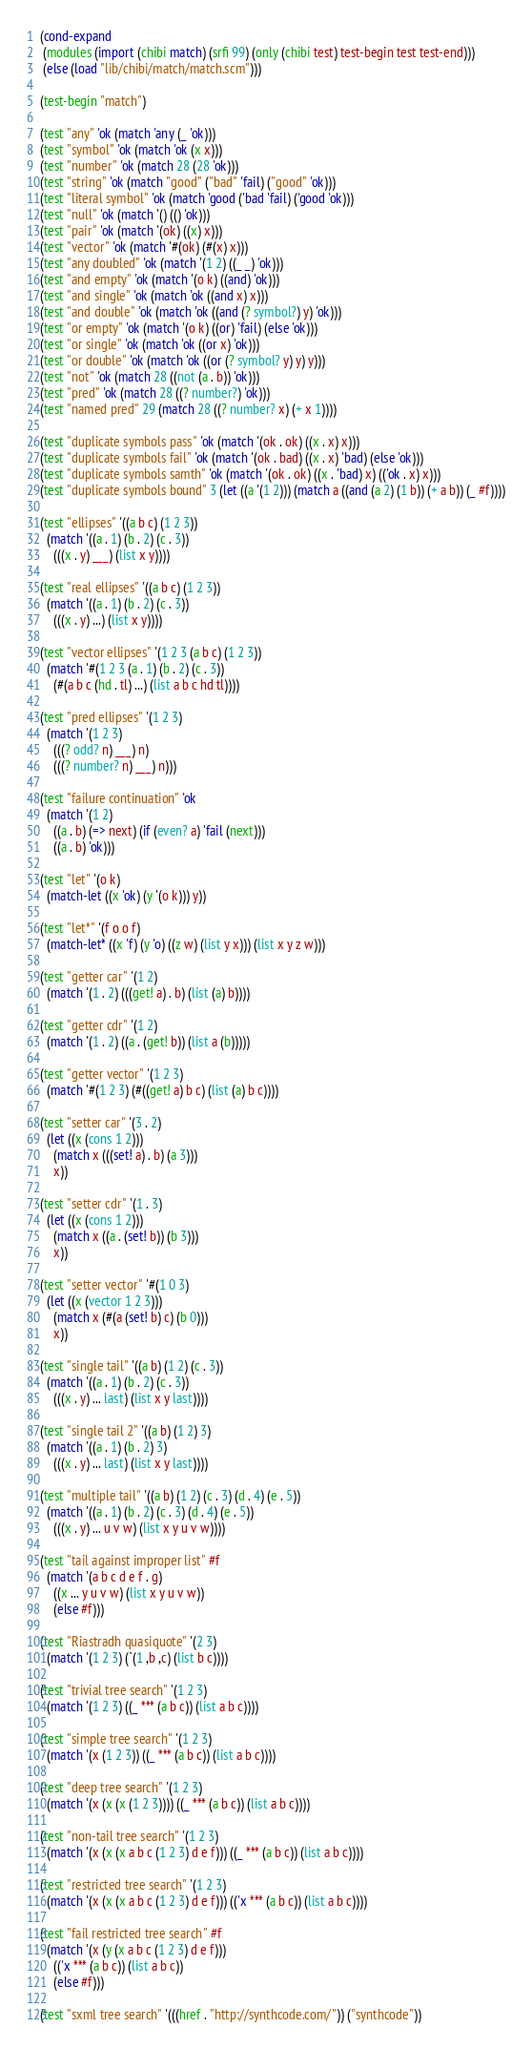<code> <loc_0><loc_0><loc_500><loc_500><_Scheme_>
(cond-expand
 (modules (import (chibi match) (srfi 99) (only (chibi test) test-begin test test-end)))
 (else (load "lib/chibi/match/match.scm")))

(test-begin "match")

(test "any" 'ok (match 'any (_ 'ok)))
(test "symbol" 'ok (match 'ok (x x)))
(test "number" 'ok (match 28 (28 'ok)))
(test "string" 'ok (match "good" ("bad" 'fail) ("good" 'ok)))
(test "literal symbol" 'ok (match 'good ('bad 'fail) ('good 'ok)))
(test "null" 'ok (match '() (() 'ok)))
(test "pair" 'ok (match '(ok) ((x) x)))
(test "vector" 'ok (match '#(ok) (#(x) x)))
(test "any doubled" 'ok (match '(1 2) ((_ _) 'ok)))
(test "and empty" 'ok (match '(o k) ((and) 'ok)))
(test "and single" 'ok (match 'ok ((and x) x)))
(test "and double" 'ok (match 'ok ((and (? symbol?) y) 'ok)))
(test "or empty" 'ok (match '(o k) ((or) 'fail) (else 'ok)))
(test "or single" 'ok (match 'ok ((or x) 'ok)))
(test "or double" 'ok (match 'ok ((or (? symbol? y) y) y)))
(test "not" 'ok (match 28 ((not (a . b)) 'ok)))
(test "pred" 'ok (match 28 ((? number?) 'ok)))
(test "named pred" 29 (match 28 ((? number? x) (+ x 1))))

(test "duplicate symbols pass" 'ok (match '(ok . ok) ((x . x) x)))
(test "duplicate symbols fail" 'ok (match '(ok . bad) ((x . x) 'bad) (else 'ok)))
(test "duplicate symbols samth" 'ok (match '(ok . ok) ((x . 'bad) x) (('ok . x) x)))
(test "duplicate symbols bound" 3 (let ((a '(1 2))) (match a ((and (a 2) (1 b)) (+ a b)) (_ #f))))

(test "ellipses" '((a b c) (1 2 3))
  (match '((a . 1) (b . 2) (c . 3))
    (((x . y) ___) (list x y))))

(test "real ellipses" '((a b c) (1 2 3))
  (match '((a . 1) (b . 2) (c . 3))
    (((x . y) ...) (list x y))))

(test "vector ellipses" '(1 2 3 (a b c) (1 2 3))
  (match '#(1 2 3 (a . 1) (b . 2) (c . 3))
    (#(a b c (hd . tl) ...) (list a b c hd tl))))

(test "pred ellipses" '(1 2 3)
  (match '(1 2 3)
    (((? odd? n) ___) n)
    (((? number? n) ___) n)))

(test "failure continuation" 'ok
  (match '(1 2)
    ((a . b) (=> next) (if (even? a) 'fail (next)))
    ((a . b) 'ok)))

(test "let" '(o k)
  (match-let ((x 'ok) (y '(o k))) y))

(test "let*" '(f o o f)
  (match-let* ((x 'f) (y 'o) ((z w) (list y x))) (list x y z w)))

(test "getter car" '(1 2)
  (match '(1 . 2) (((get! a) . b) (list (a) b))))

(test "getter cdr" '(1 2)
  (match '(1 . 2) ((a . (get! b)) (list a (b)))))

(test "getter vector" '(1 2 3)
  (match '#(1 2 3) (#((get! a) b c) (list (a) b c))))

(test "setter car" '(3 . 2)
  (let ((x (cons 1 2)))
    (match x (((set! a) . b) (a 3)))
    x))

(test "setter cdr" '(1 . 3)
  (let ((x (cons 1 2)))
    (match x ((a . (set! b)) (b 3)))
    x))

(test "setter vector" '#(1 0 3)
  (let ((x (vector 1 2 3)))
    (match x (#(a (set! b) c) (b 0)))
    x))

(test "single tail" '((a b) (1 2) (c . 3))
  (match '((a . 1) (b . 2) (c . 3))
    (((x . y) ... last) (list x y last))))

(test "single tail 2" '((a b) (1 2) 3)
  (match '((a . 1) (b . 2) 3)
    (((x . y) ... last) (list x y last))))

(test "multiple tail" '((a b) (1 2) (c . 3) (d . 4) (e . 5))
  (match '((a . 1) (b . 2) (c . 3) (d . 4) (e . 5))
    (((x . y) ... u v w) (list x y u v w))))

(test "tail against improper list" #f
  (match '(a b c d e f . g)
    ((x ... y u v w) (list x y u v w))
    (else #f)))

(test "Riastradh quasiquote" '(2 3)
  (match '(1 2 3) (`(1 ,b ,c) (list b c))))

(test "trivial tree search" '(1 2 3)
  (match '(1 2 3) ((_ *** (a b c)) (list a b c))))

(test "simple tree search" '(1 2 3)
  (match '(x (1 2 3)) ((_ *** (a b c)) (list a b c))))

(test "deep tree search" '(1 2 3)
  (match '(x (x (x (1 2 3)))) ((_ *** (a b c)) (list a b c))))

(test "non-tail tree search" '(1 2 3)
  (match '(x (x (x a b c (1 2 3) d e f))) ((_ *** (a b c)) (list a b c))))

(test "restricted tree search" '(1 2 3)
  (match '(x (x (x a b c (1 2 3) d e f))) (('x *** (a b c)) (list a b c))))

(test "fail restricted tree search" #f
  (match '(x (y (x a b c (1 2 3) d e f)))
    (('x *** (a b c)) (list a b c))
    (else #f)))

(test "sxml tree search" '(((href . "http://synthcode.com/")) ("synthcode"))</code> 